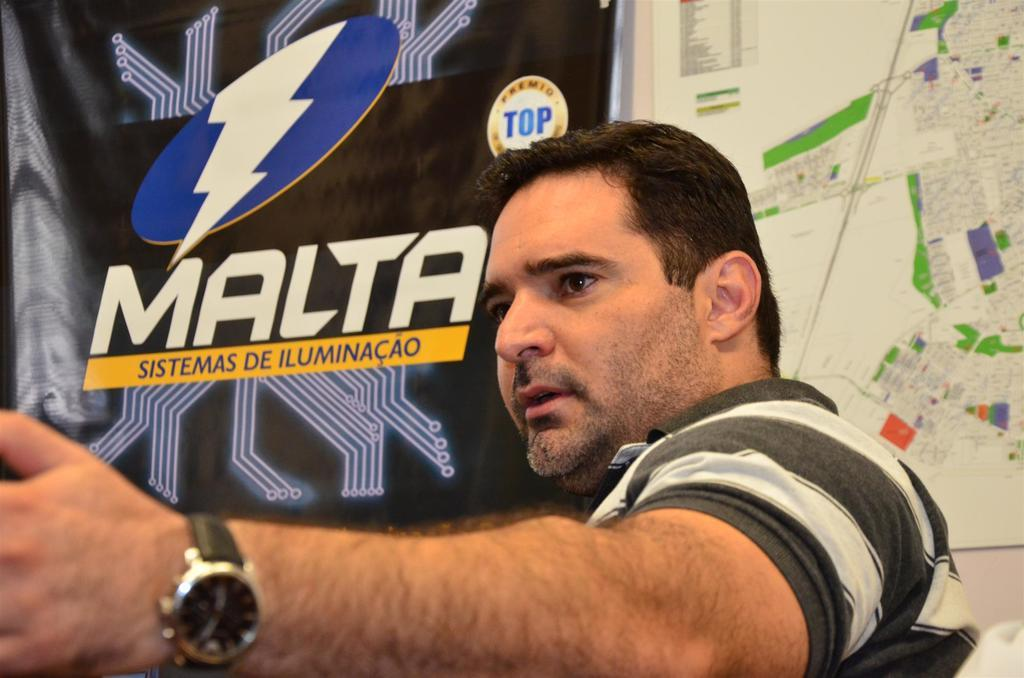Provide a one-sentence caption for the provided image. A man wearing a watch with a sign about Malta behind him. 